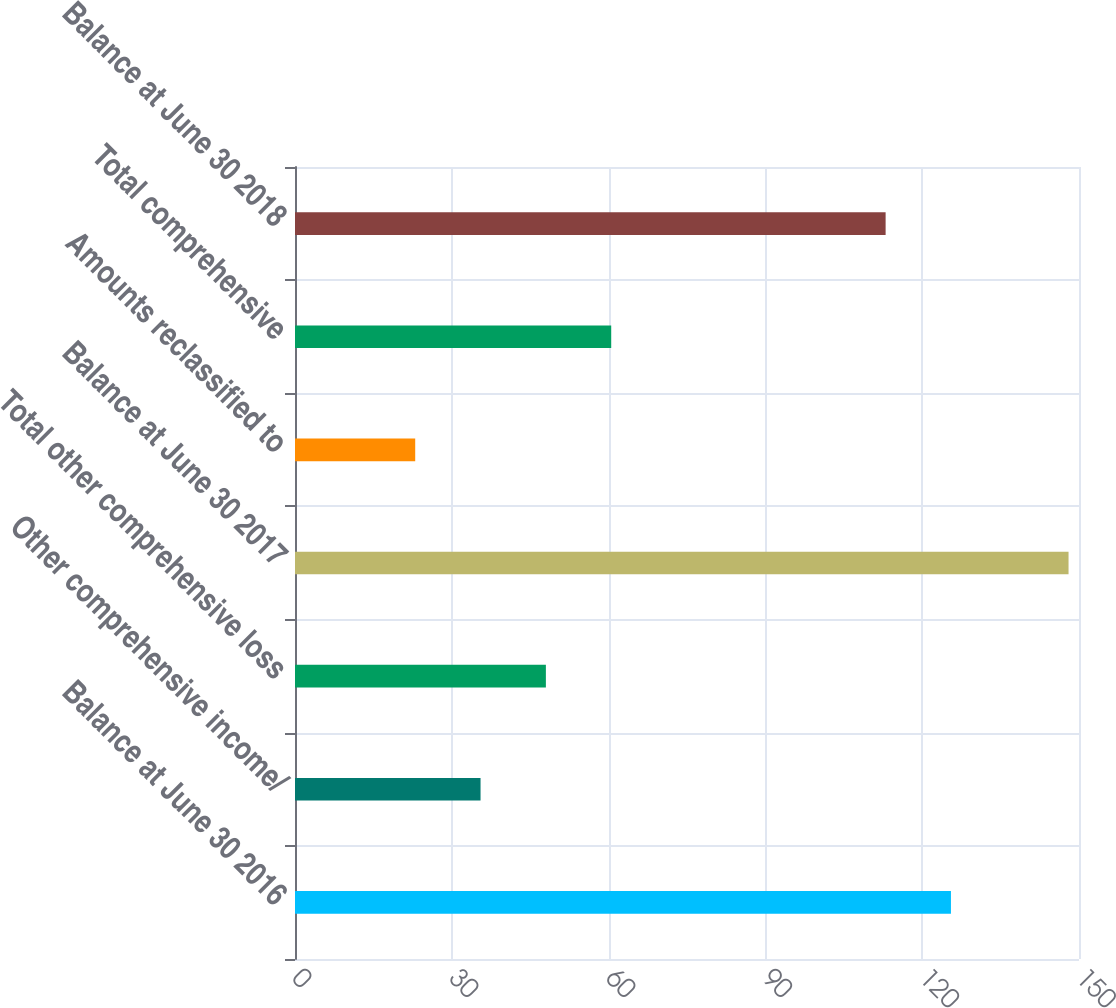<chart> <loc_0><loc_0><loc_500><loc_500><bar_chart><fcel>Balance at June 30 2016<fcel>Other comprehensive income/<fcel>Total other comprehensive loss<fcel>Balance at June 30 2017<fcel>Amounts reclassified to<fcel>Total comprehensive<fcel>Balance at June 30 2018<nl><fcel>125.5<fcel>35.5<fcel>48<fcel>148<fcel>23<fcel>60.5<fcel>113<nl></chart> 